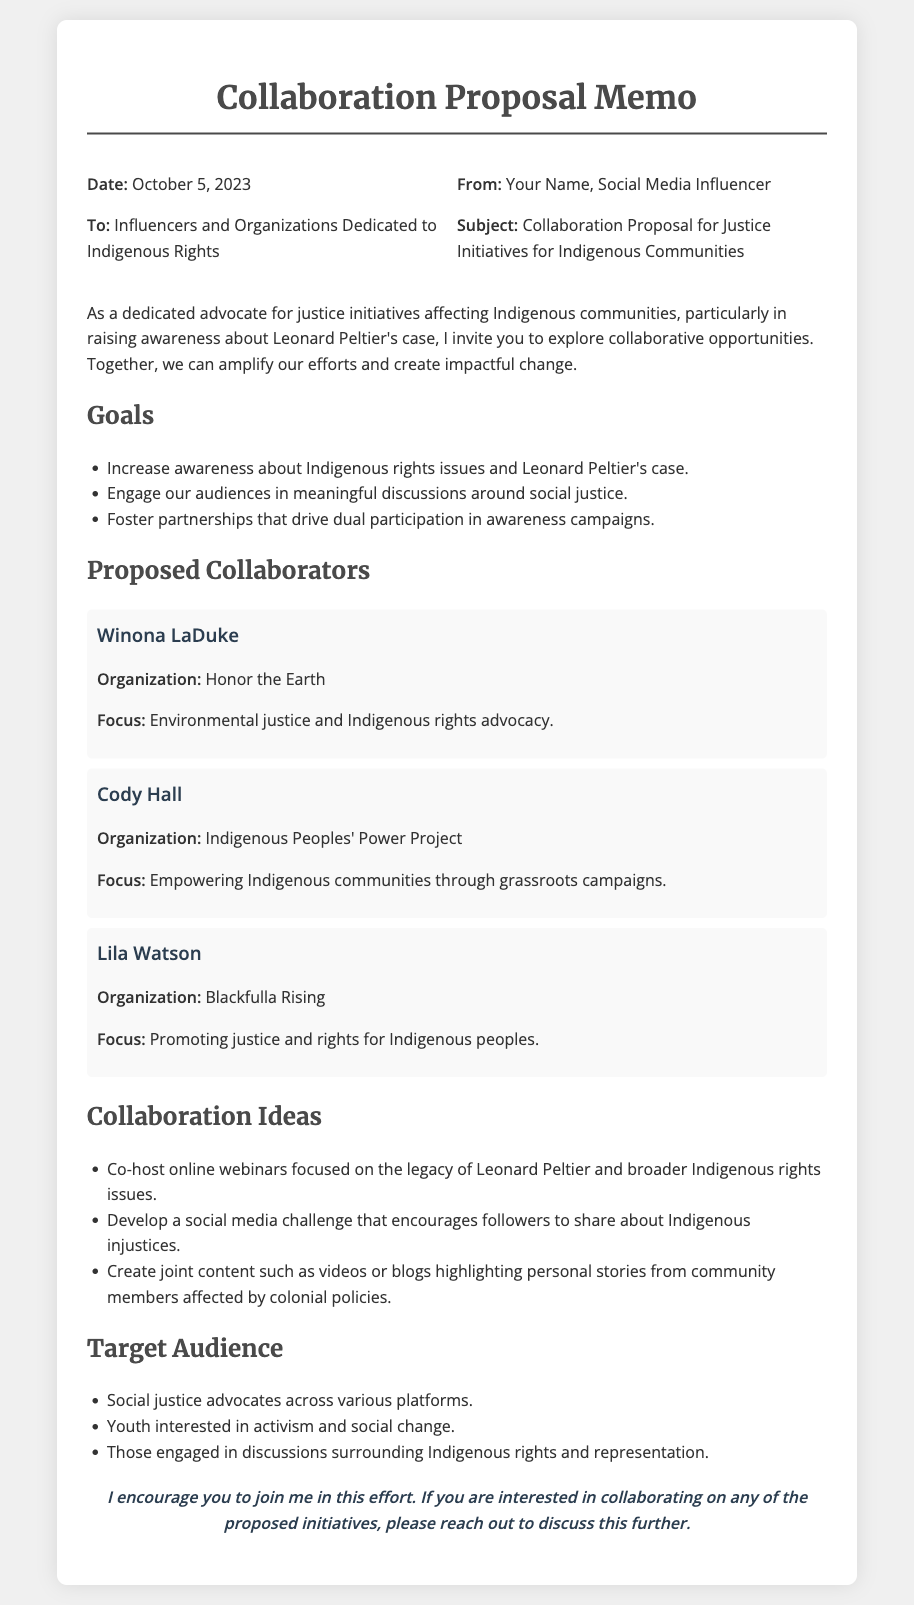What is the date of the memo? The date is mentioned in the header of the memo as October 5, 2023.
Answer: October 5, 2023 Who is the memo addressed to? The recipient of the memo is specified in the header as Influencers and Organizations Dedicated to Indigenous Rights.
Answer: Influencers and Organizations Dedicated to Indigenous Rights What is one of the goals listed in the memo? The goals section outlines specific objectives, one of which is to increase awareness about Indigenous rights issues and Leonard Peltier's case.
Answer: Increase awareness about Indigenous rights issues and Leonard Peltier's case Name a proposed collaborator mentioned in the memo. The proposed collaborators are listed, including Winona LaDuke.
Answer: Winona LaDuke What is one collaboration idea suggested in the memo? In the ideas section, a collaboration idea includes co-hosting online webinars focused on the legacy of Leonard Peltier.
Answer: Co-host online webinars focused on the legacy of Leonard Peltier What type of audience is targeted according to the memo? The document describes the target audience, which includes social justice advocates across various platforms.
Answer: Social justice advocates across various platforms What is a specific organization mentioned in the proposed collaborators section? The proposed collaborators include organizations, one of which is Honor the Earth.
Answer: Honor the Earth What action does the author encourage at the end of the memo? The closing statement in the memo invites readers to reach out if they are interested in collaborating on any proposed initiatives.
Answer: Reach out to discuss this further 